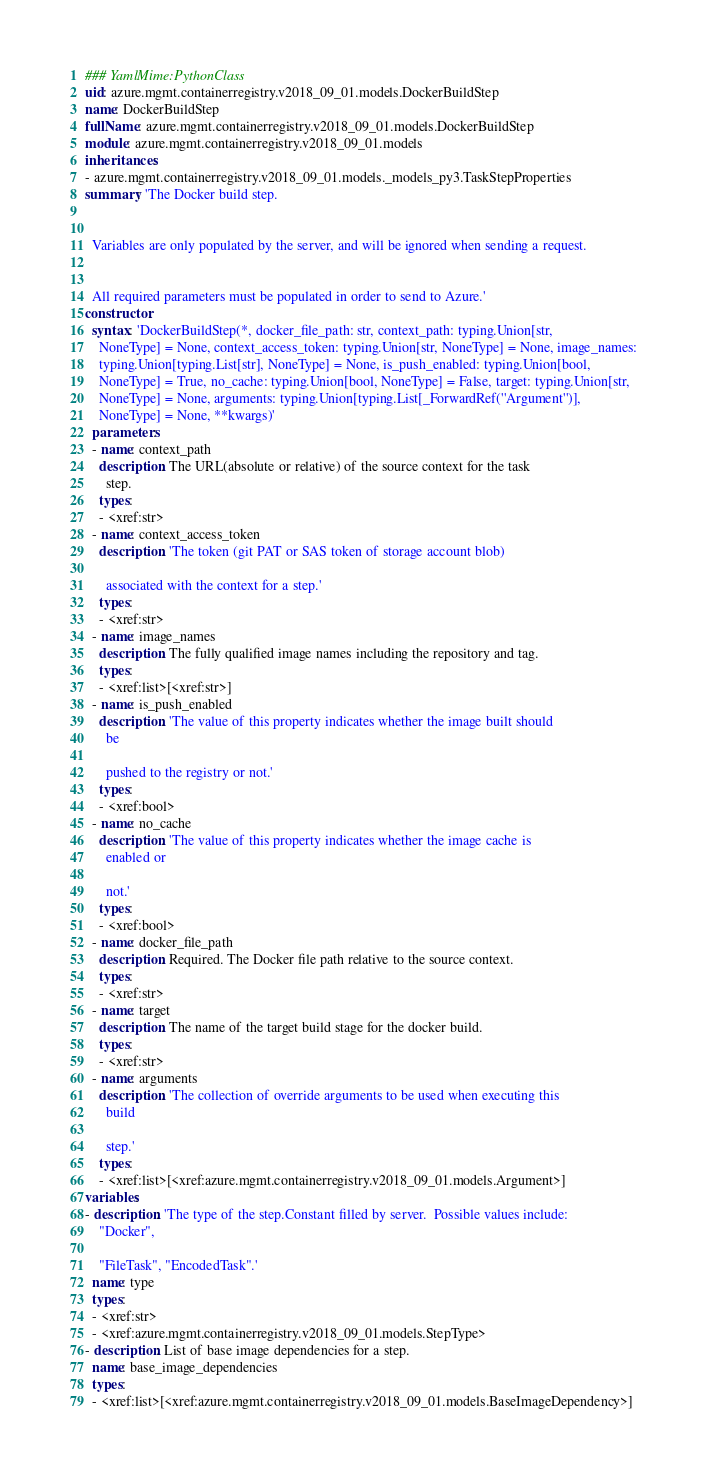<code> <loc_0><loc_0><loc_500><loc_500><_YAML_>### YamlMime:PythonClass
uid: azure.mgmt.containerregistry.v2018_09_01.models.DockerBuildStep
name: DockerBuildStep
fullName: azure.mgmt.containerregistry.v2018_09_01.models.DockerBuildStep
module: azure.mgmt.containerregistry.v2018_09_01.models
inheritances:
- azure.mgmt.containerregistry.v2018_09_01.models._models_py3.TaskStepProperties
summary: 'The Docker build step.


  Variables are only populated by the server, and will be ignored when sending a request.


  All required parameters must be populated in order to send to Azure.'
constructor:
  syntax: 'DockerBuildStep(*, docker_file_path: str, context_path: typing.Union[str,
    NoneType] = None, context_access_token: typing.Union[str, NoneType] = None, image_names:
    typing.Union[typing.List[str], NoneType] = None, is_push_enabled: typing.Union[bool,
    NoneType] = True, no_cache: typing.Union[bool, NoneType] = False, target: typing.Union[str,
    NoneType] = None, arguments: typing.Union[typing.List[_ForwardRef(''Argument'')],
    NoneType] = None, **kwargs)'
  parameters:
  - name: context_path
    description: The URL(absolute or relative) of the source context for the task
      step.
    types:
    - <xref:str>
  - name: context_access_token
    description: 'The token (git PAT or SAS token of storage account blob)

      associated with the context for a step.'
    types:
    - <xref:str>
  - name: image_names
    description: The fully qualified image names including the repository and tag.
    types:
    - <xref:list>[<xref:str>]
  - name: is_push_enabled
    description: 'The value of this property indicates whether the image built should
      be

      pushed to the registry or not.'
    types:
    - <xref:bool>
  - name: no_cache
    description: 'The value of this property indicates whether the image cache is
      enabled or

      not.'
    types:
    - <xref:bool>
  - name: docker_file_path
    description: Required. The Docker file path relative to the source context.
    types:
    - <xref:str>
  - name: target
    description: The name of the target build stage for the docker build.
    types:
    - <xref:str>
  - name: arguments
    description: 'The collection of override arguments to be used when executing this
      build

      step.'
    types:
    - <xref:list>[<xref:azure.mgmt.containerregistry.v2018_09_01.models.Argument>]
variables:
- description: 'The type of the step.Constant filled by server.  Possible values include:
    "Docker",

    "FileTask", "EncodedTask".'
  name: type
  types:
  - <xref:str>
  - <xref:azure.mgmt.containerregistry.v2018_09_01.models.StepType>
- description: List of base image dependencies for a step.
  name: base_image_dependencies
  types:
  - <xref:list>[<xref:azure.mgmt.containerregistry.v2018_09_01.models.BaseImageDependency>]
</code> 